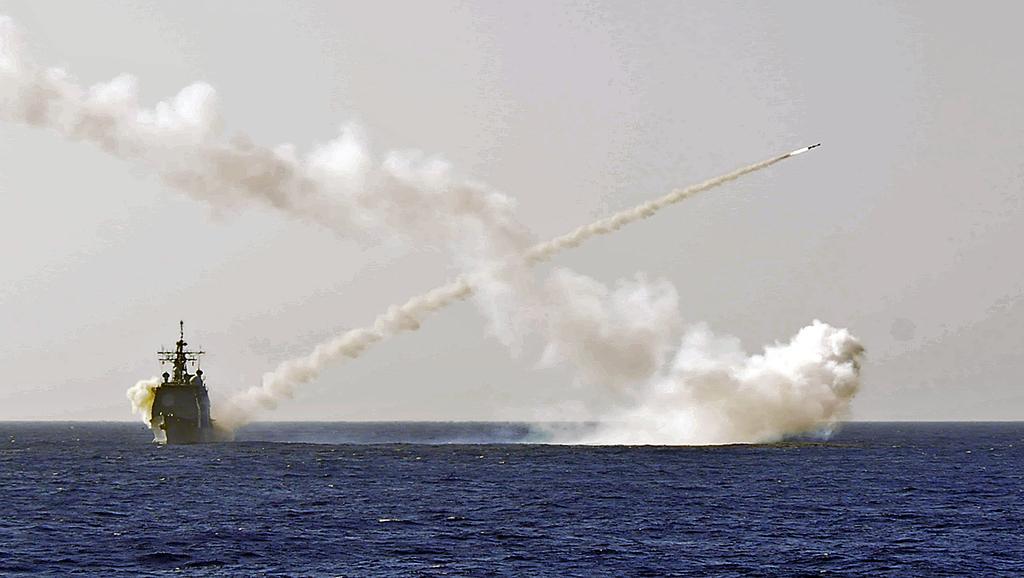Describe this image in one or two sentences. In this picture we can see a boat on the water. We can see the smoke and the sky. 